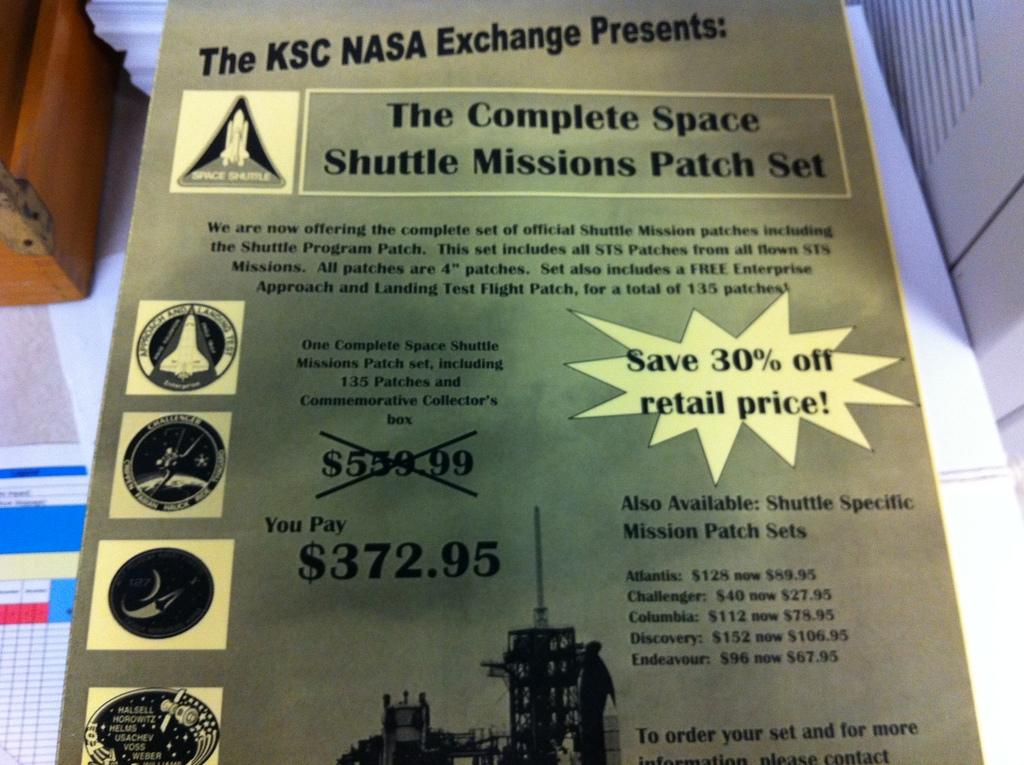What price do you pay?
Your response must be concise. 372.95. How much can you save?
Your answer should be compact. 30%. 